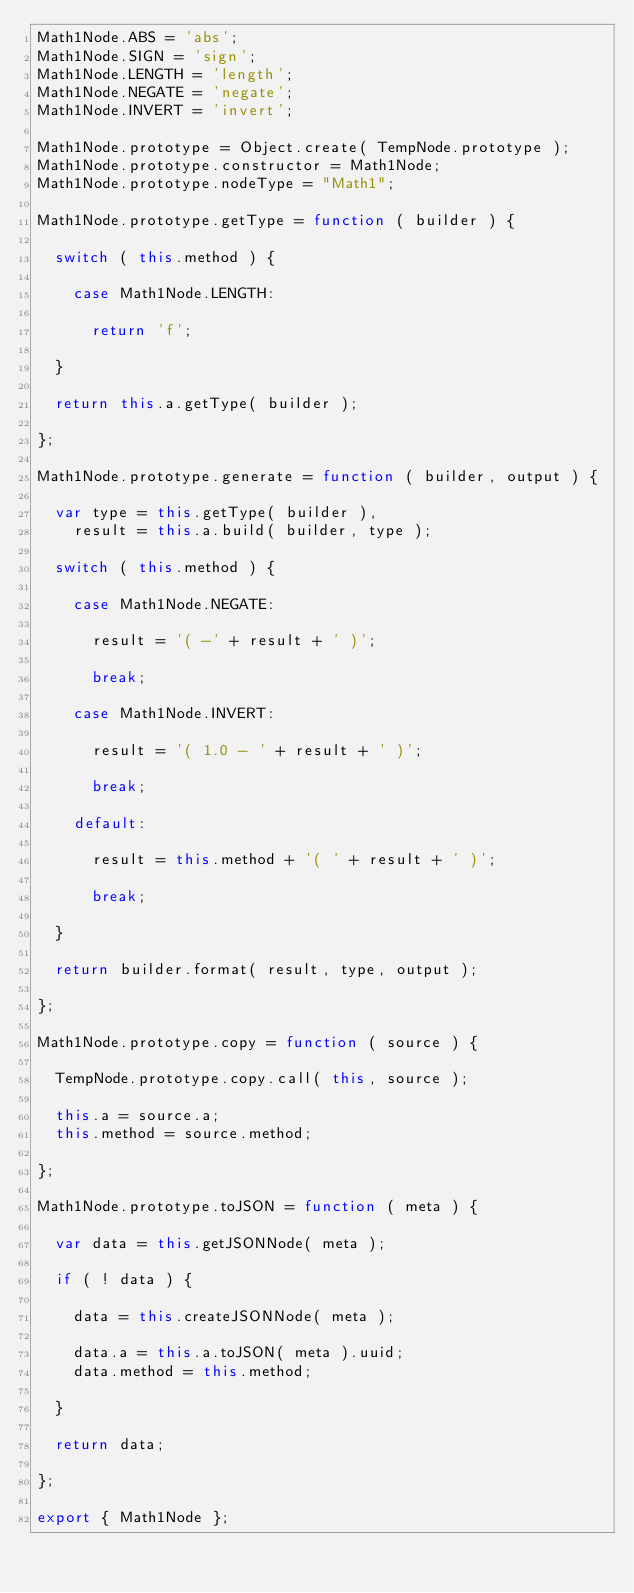<code> <loc_0><loc_0><loc_500><loc_500><_JavaScript_>Math1Node.ABS = 'abs';
Math1Node.SIGN = 'sign';
Math1Node.LENGTH = 'length';
Math1Node.NEGATE = 'negate';
Math1Node.INVERT = 'invert';

Math1Node.prototype = Object.create( TempNode.prototype );
Math1Node.prototype.constructor = Math1Node;
Math1Node.prototype.nodeType = "Math1";

Math1Node.prototype.getType = function ( builder ) {

	switch ( this.method ) {

		case Math1Node.LENGTH:

			return 'f';

	}

	return this.a.getType( builder );

};

Math1Node.prototype.generate = function ( builder, output ) {

	var type = this.getType( builder ),
		result = this.a.build( builder, type );

	switch ( this.method ) {

		case Math1Node.NEGATE:

			result = '( -' + result + ' )';

			break;

		case Math1Node.INVERT:

			result = '( 1.0 - ' + result + ' )';

			break;

		default:

			result = this.method + '( ' + result + ' )';

			break;

	}

	return builder.format( result, type, output );

};

Math1Node.prototype.copy = function ( source ) {

	TempNode.prototype.copy.call( this, source );

	this.a = source.a;
	this.method = source.method;

};

Math1Node.prototype.toJSON = function ( meta ) {

	var data = this.getJSONNode( meta );

	if ( ! data ) {

		data = this.createJSONNode( meta );

		data.a = this.a.toJSON( meta ).uuid;
		data.method = this.method;

	}

	return data;

};

export { Math1Node };
</code> 